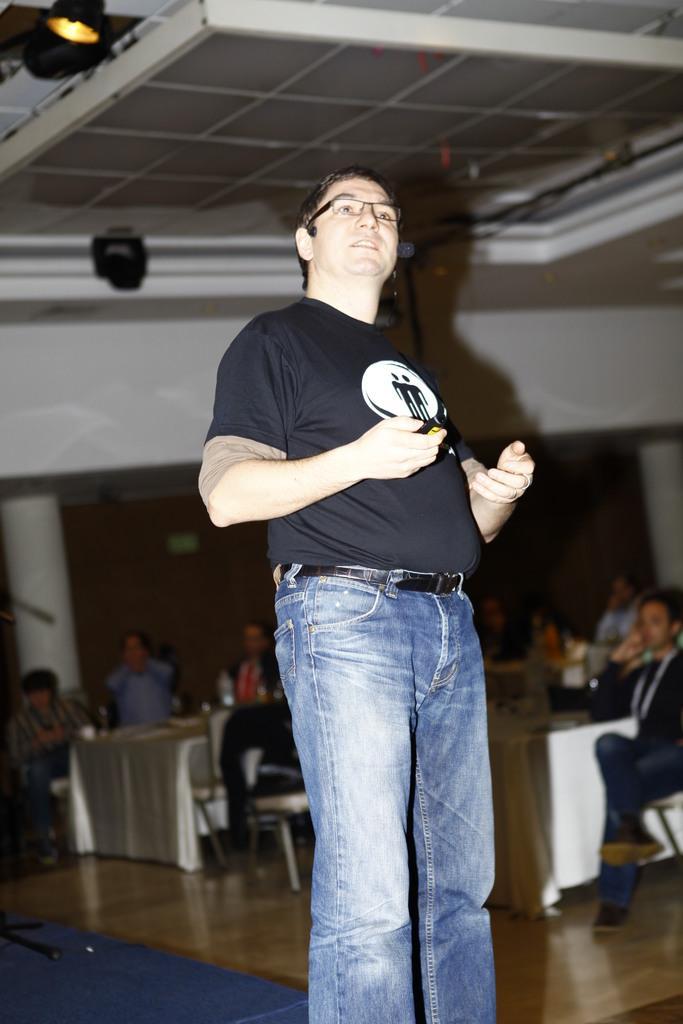Please provide a concise description of this image. In this image in the foreground there is one person standing and talking, and in the background there are group of people who are sitting on chairs and also i can see some tables. At the bottom there is floor, and in the background there is wall, pillars. At the top of the image there is ceiling and some lights. 